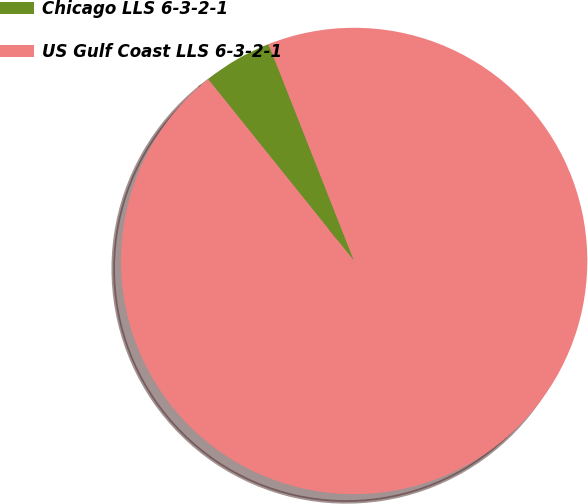Convert chart to OTSL. <chart><loc_0><loc_0><loc_500><loc_500><pie_chart><fcel>Chicago LLS 6-3-2-1<fcel>US Gulf Coast LLS 6-3-2-1<nl><fcel>4.79%<fcel>95.21%<nl></chart> 